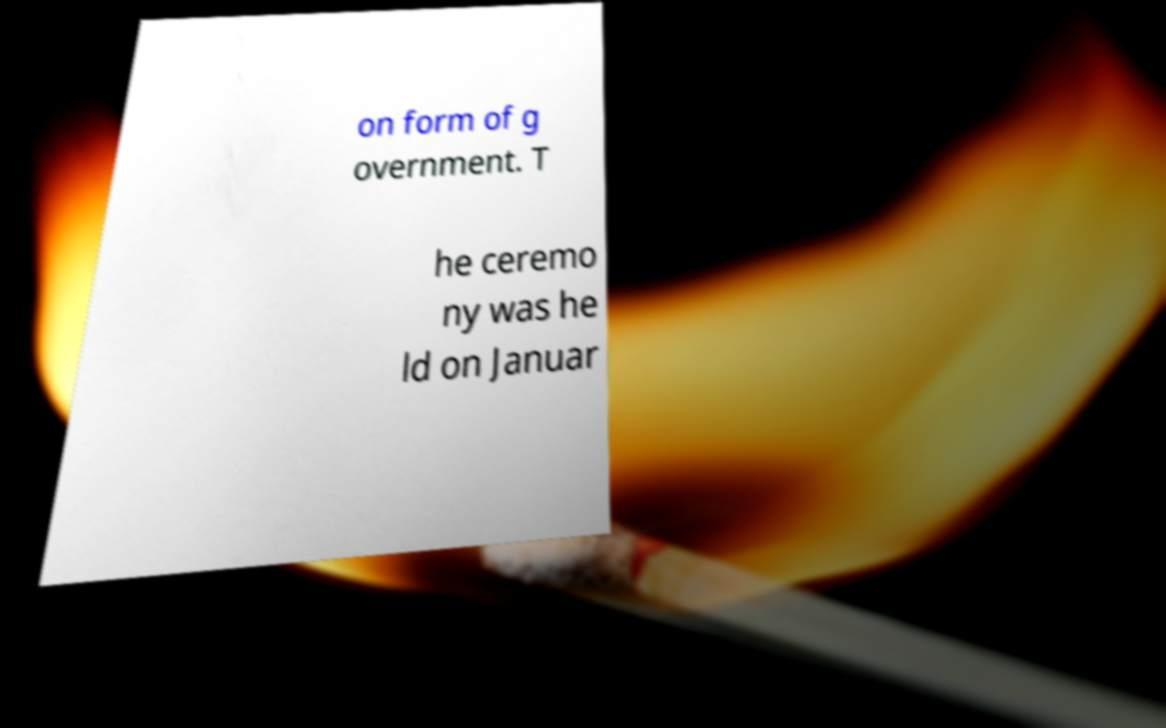Could you assist in decoding the text presented in this image and type it out clearly? on form of g overnment. T he ceremo ny was he ld on Januar 